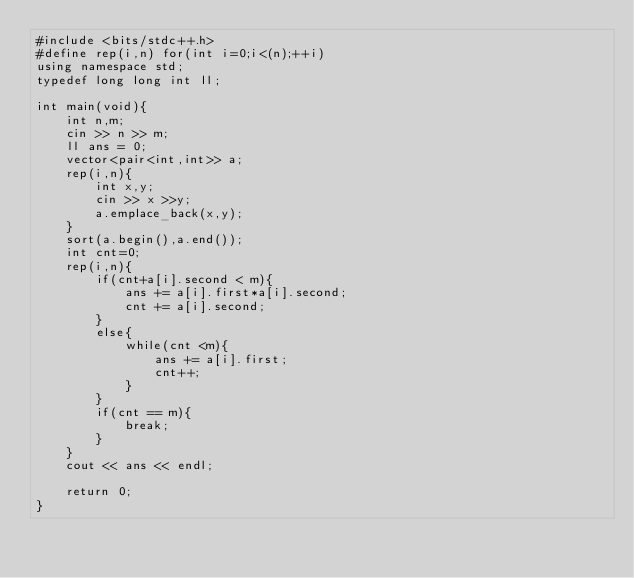<code> <loc_0><loc_0><loc_500><loc_500><_C++_>#include <bits/stdc++.h>
#define rep(i,n) for(int i=0;i<(n);++i)
using namespace std;
typedef long long int ll;

int main(void){
    int n,m;
    cin >> n >> m;
    ll ans = 0;
    vector<pair<int,int>> a;
    rep(i,n){
        int x,y;
        cin >> x >>y;
        a.emplace_back(x,y);
    }
    sort(a.begin(),a.end());
    int cnt=0;
    rep(i,n){
        if(cnt+a[i].second < m){
            ans += a[i].first*a[i].second;
            cnt += a[i].second;
        }
        else{
            while(cnt <m){
                ans += a[i].first;
                cnt++;
            }
        }
        if(cnt == m){
            break;
        }
    }
    cout << ans << endl;
 
    return 0;
}



































</code> 